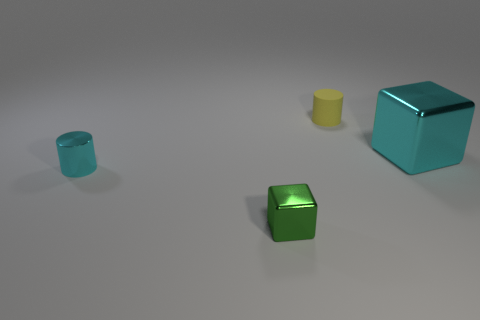Add 2 yellow objects. How many objects exist? 6 Subtract 0 brown spheres. How many objects are left? 4 Subtract all red blocks. Subtract all purple balls. How many blocks are left? 2 Subtract all small rubber cylinders. Subtract all cyan metallic cylinders. How many objects are left? 2 Add 2 big cubes. How many big cubes are left? 3 Add 1 cyan cubes. How many cyan cubes exist? 2 